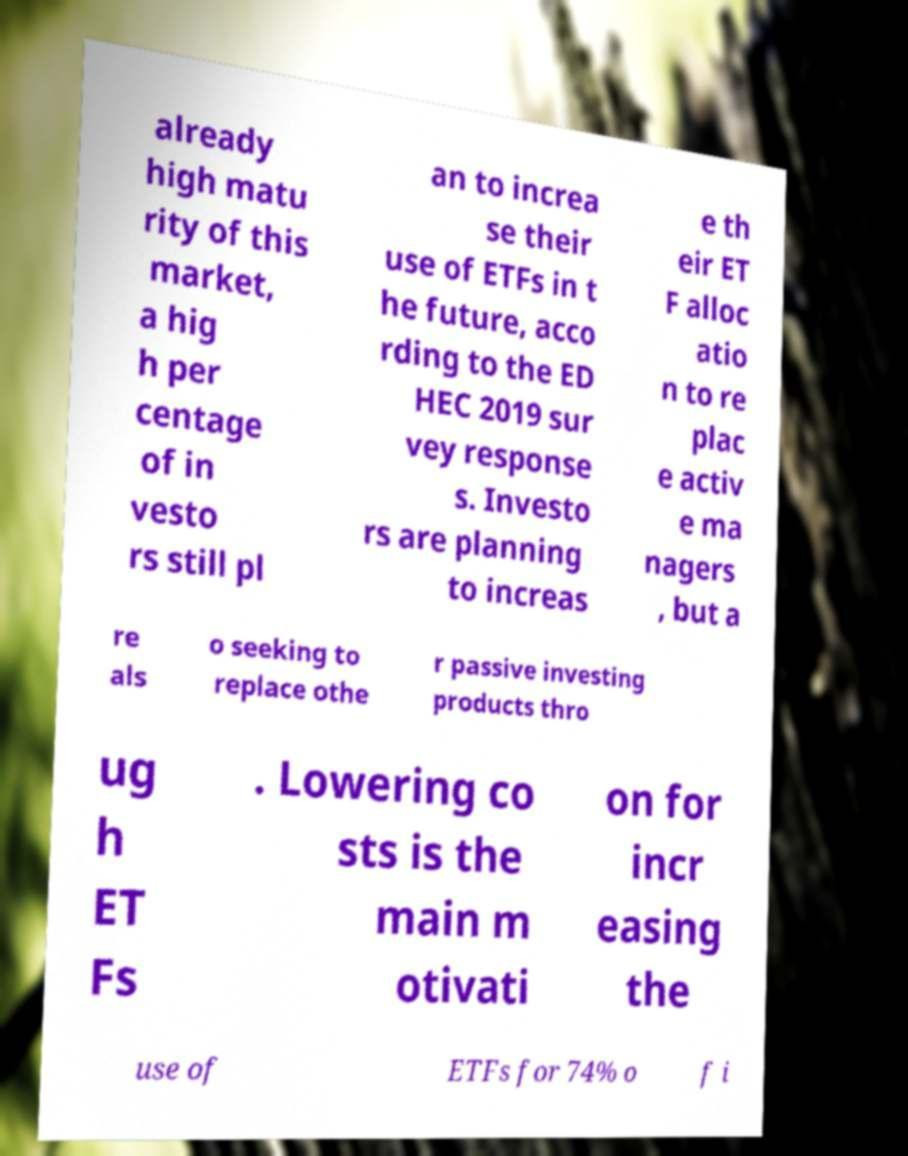What messages or text are displayed in this image? I need them in a readable, typed format. already high matu rity of this market, a hig h per centage of in vesto rs still pl an to increa se their use of ETFs in t he future, acco rding to the ED HEC 2019 sur vey response s. Investo rs are planning to increas e th eir ET F alloc atio n to re plac e activ e ma nagers , but a re als o seeking to replace othe r passive investing products thro ug h ET Fs . Lowering co sts is the main m otivati on for incr easing the use of ETFs for 74% o f i 